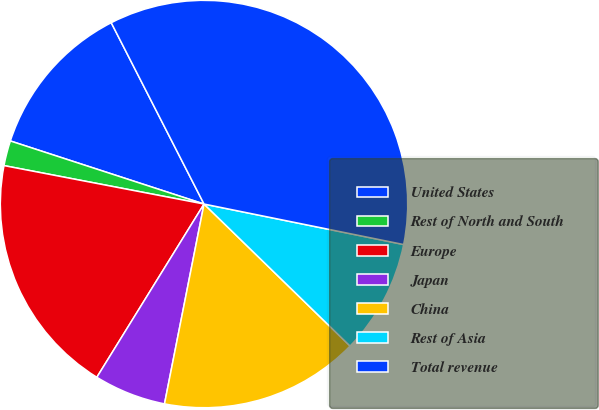<chart> <loc_0><loc_0><loc_500><loc_500><pie_chart><fcel>United States<fcel>Rest of North and South<fcel>Europe<fcel>Japan<fcel>China<fcel>Rest of Asia<fcel>Total revenue<nl><fcel>12.46%<fcel>1.99%<fcel>19.2%<fcel>5.71%<fcel>15.83%<fcel>9.09%<fcel>35.71%<nl></chart> 